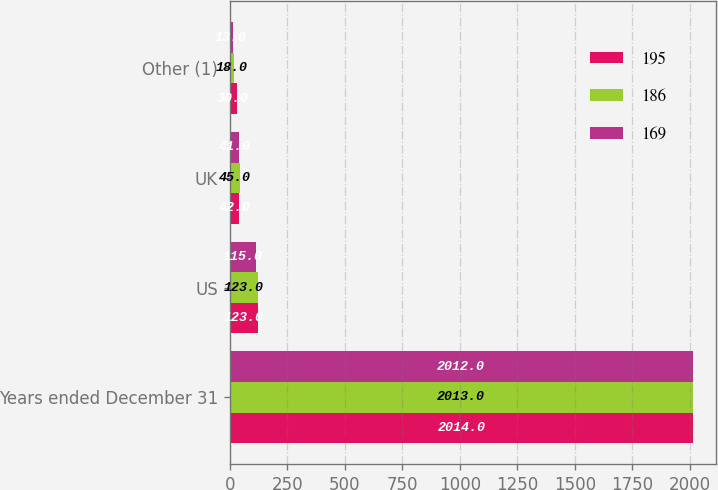<chart> <loc_0><loc_0><loc_500><loc_500><stacked_bar_chart><ecel><fcel>Years ended December 31<fcel>US<fcel>UK<fcel>Other (1)<nl><fcel>195<fcel>2014<fcel>123<fcel>42<fcel>30<nl><fcel>186<fcel>2013<fcel>123<fcel>45<fcel>18<nl><fcel>169<fcel>2012<fcel>115<fcel>41<fcel>13<nl></chart> 